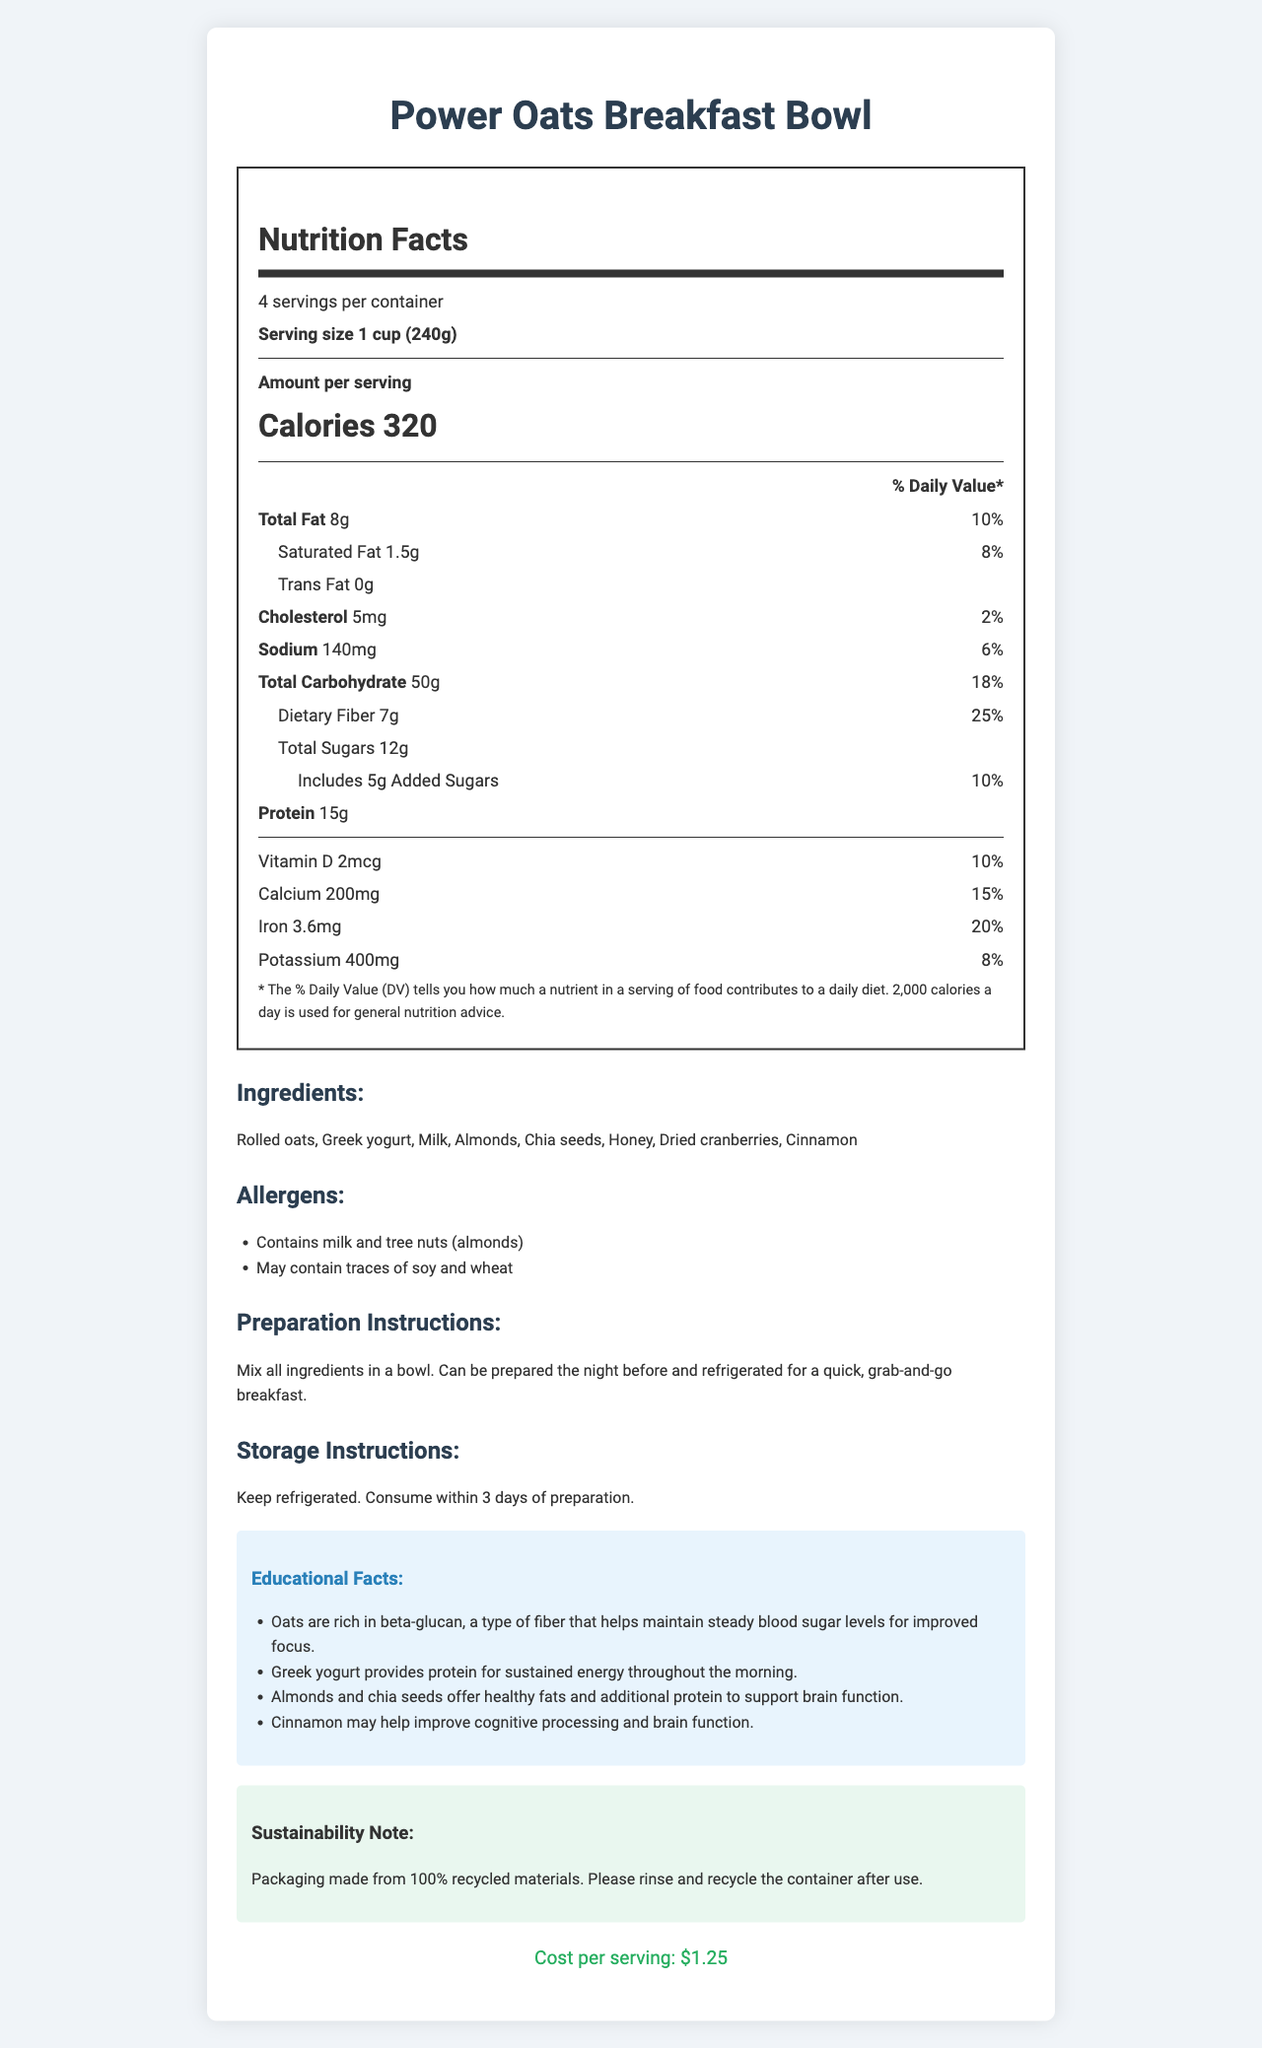what is the serving size? The serving size is explicitly mentioned in the "Nutrition Facts" section under "Serving size."
Answer: 1 cup (240g) how many servings are in one container? The number of servings per container is provided directly under the product name in the "Nutrition Facts" section.
Answer: 4 how many grams of protein are in one serving? The amount of protein per serving is indicated in the "Nutrition Facts" section as "Protein 15g."
Answer: 15g what is the cost per serving? The cost per serving is provided at the bottom of the document in the green "Cost" section.
Answer: $1.25 list three ingredients found in the Power Oats Breakfast Bowl. The ingredients are listed under the "Ingredients" section. Three examples are "Rolled oats," "Greek yogurt," and "Milk."
Answer: Rolled oats, Greek yogurt, Milk what percentage of the daily value of dietary fiber does one serving provide? The daily value percentage for dietary fiber is indicated in the "Nutrition Facts" section as "Dietary Fiber 7g 25%."
Answer: 25% which of the following is NOT an ingredient in the Power Oats Breakfast Bowl? A. Honey B. Almonds C. Peanuts D. Dried cranberries Peanuts are not listed in the "Ingredients" section; Honey, Almonds, and Dried cranberries are listed.
Answer: C. Peanuts which nutrient has the highest daily value percentage? A. Calcium B. Iron C. Sodium D. Protein The "Nutrition Facts" section reveals that Iron has a daily value percentage of 20%, the highest among options A, B, C, and D.
Answer: B. Iron does the product contain any tree nuts? The allergens section states that the product "Contains milk and tree nuts (almonds)."
Answer: Yes summarize the main idea of the document The document is a comprehensive nutrition label that includes all essential details about the Power Oats Breakfast Bowl, such as nutritional content, allergens, ingredients, preparation instructions, and educational insights related to health benefits.
Answer: The document provides detailed nutritional information about the Power Oats Breakfast Bowl, including serving size, calories, nutrients, ingredients, allergens, preparation and storage instructions, cost per serving, educational facts, and sustainability notes. It highlights components beneficial for student focus and energy. what is the cost of preparing a whole container? There is not enough information to determine the total cost for a whole container. The document only provides the cost per serving. Assuming there are 4 servings per container and each serving costs $1.25, the calculation would be $1.25 * 4 = $5.00, but the total expenditure depends on additional factors not provided.
Answer: $5.00 